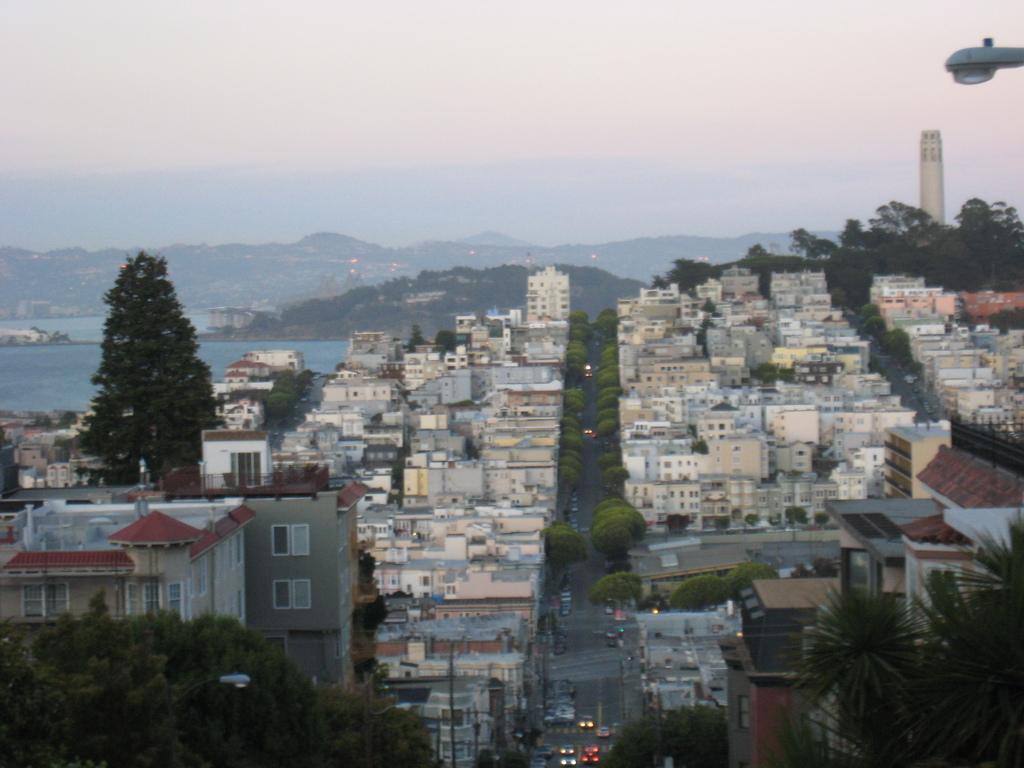Can you describe this image briefly? In this picture we can see few buildings, trees, lights and vehicles on the road, in the background we can find a tower, hills and water. 